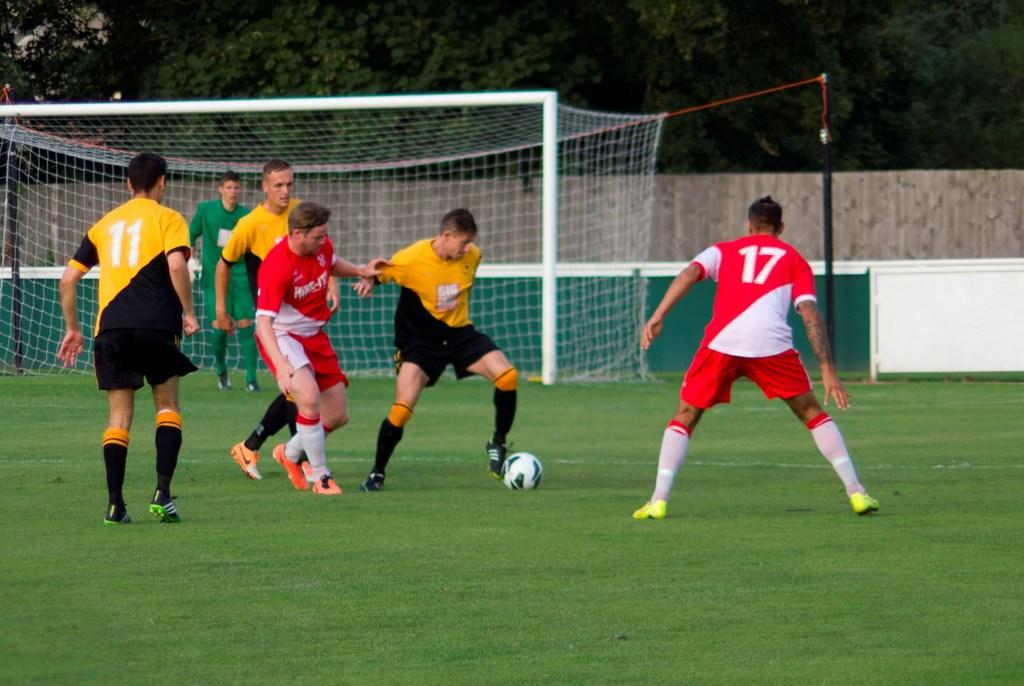Provide a one-sentence caption for the provided image. A group of soccer players chase the ball including jersey 17. 